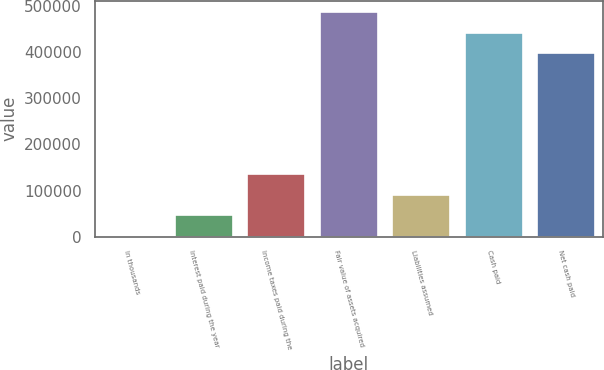Convert chart to OTSL. <chart><loc_0><loc_0><loc_500><loc_500><bar_chart><fcel>In thousands<fcel>Interest paid during the year<fcel>Income taxes paid during the<fcel>Fair value of assets acquired<fcel>Liabilities assumed<fcel>Cash paid<fcel>Net cash paid<nl><fcel>2008<fcel>46547.8<fcel>135627<fcel>487212<fcel>91087.6<fcel>442672<fcel>398132<nl></chart> 